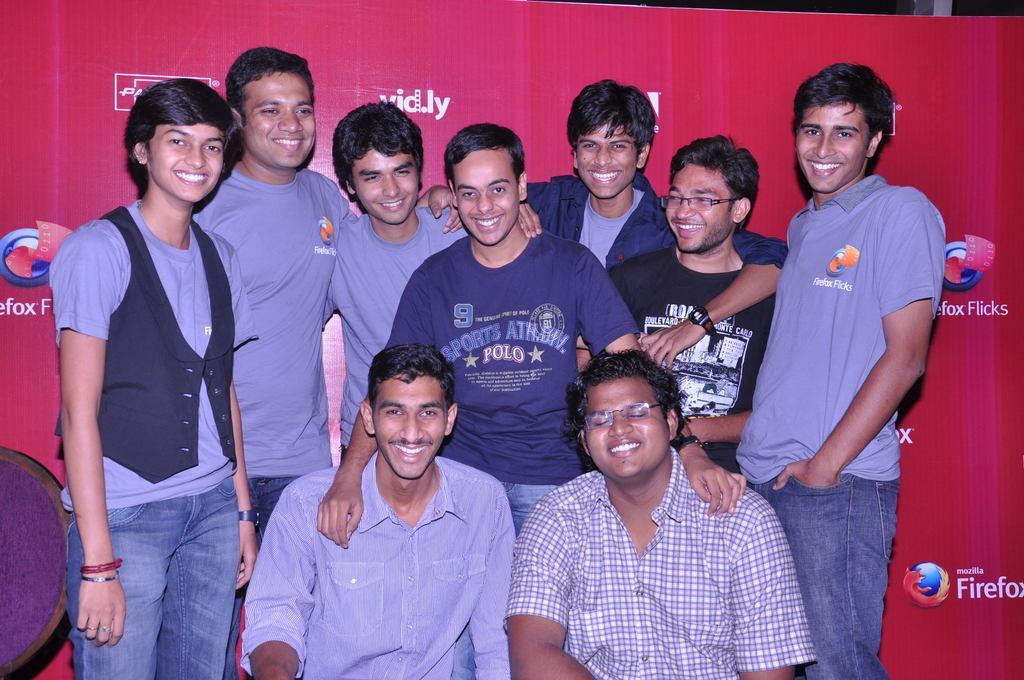Describe this image in one or two sentences. In the center of the image we can see some people are standing and some of them are sitting and smiling. In the background of the image we can see the board. On the board we can see the logos and text. In the bottom left corner we can see a chair. 